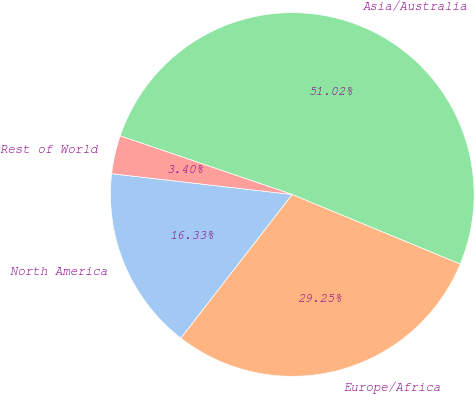<chart> <loc_0><loc_0><loc_500><loc_500><pie_chart><fcel>North America<fcel>Europe/Africa<fcel>Asia/Australia<fcel>Rest of World<nl><fcel>16.33%<fcel>29.25%<fcel>51.02%<fcel>3.4%<nl></chart> 